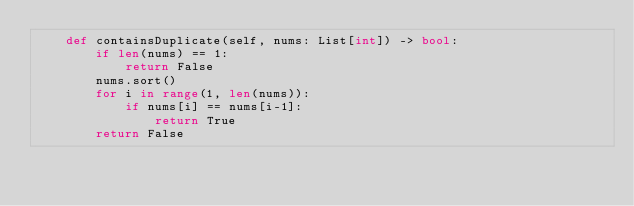<code> <loc_0><loc_0><loc_500><loc_500><_Python_>    def containsDuplicate(self, nums: List[int]) -> bool:
        if len(nums) == 1:
            return False
        nums.sort()
        for i in range(1, len(nums)):
            if nums[i] == nums[i-1]:
                return True
        return False
</code> 